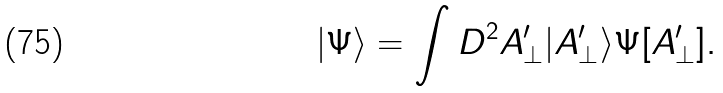Convert formula to latex. <formula><loc_0><loc_0><loc_500><loc_500>| \Psi \rangle = \int D ^ { 2 } A _ { \perp } ^ { \prime } | A _ { \perp } ^ { \prime } \rangle \Psi [ A _ { \perp } ^ { \prime } ] .</formula> 